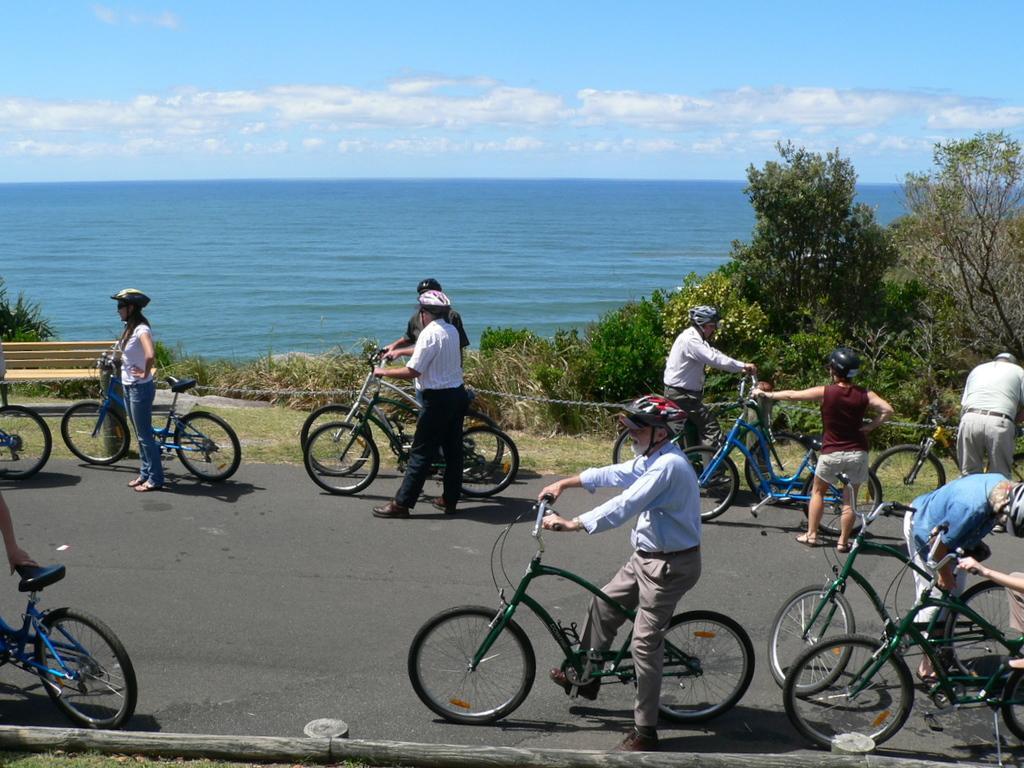How would you summarize this image in a sentence or two? In this picture there are group of people holding bicycles. Towards the left there is a woman wearing a helmet and pink t shirt, she is standing besides a bicycle, behind her there are two people holding bicycles. In the center there is a man wearing a red helmet and he is sitting on a bicycle. In the background there are group of trees, ocean and blue sky. 